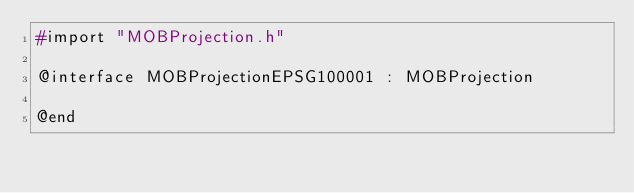Convert code to text. <code><loc_0><loc_0><loc_500><loc_500><_C_>#import "MOBProjection.h"

@interface MOBProjectionEPSG100001 : MOBProjection

@end
</code> 